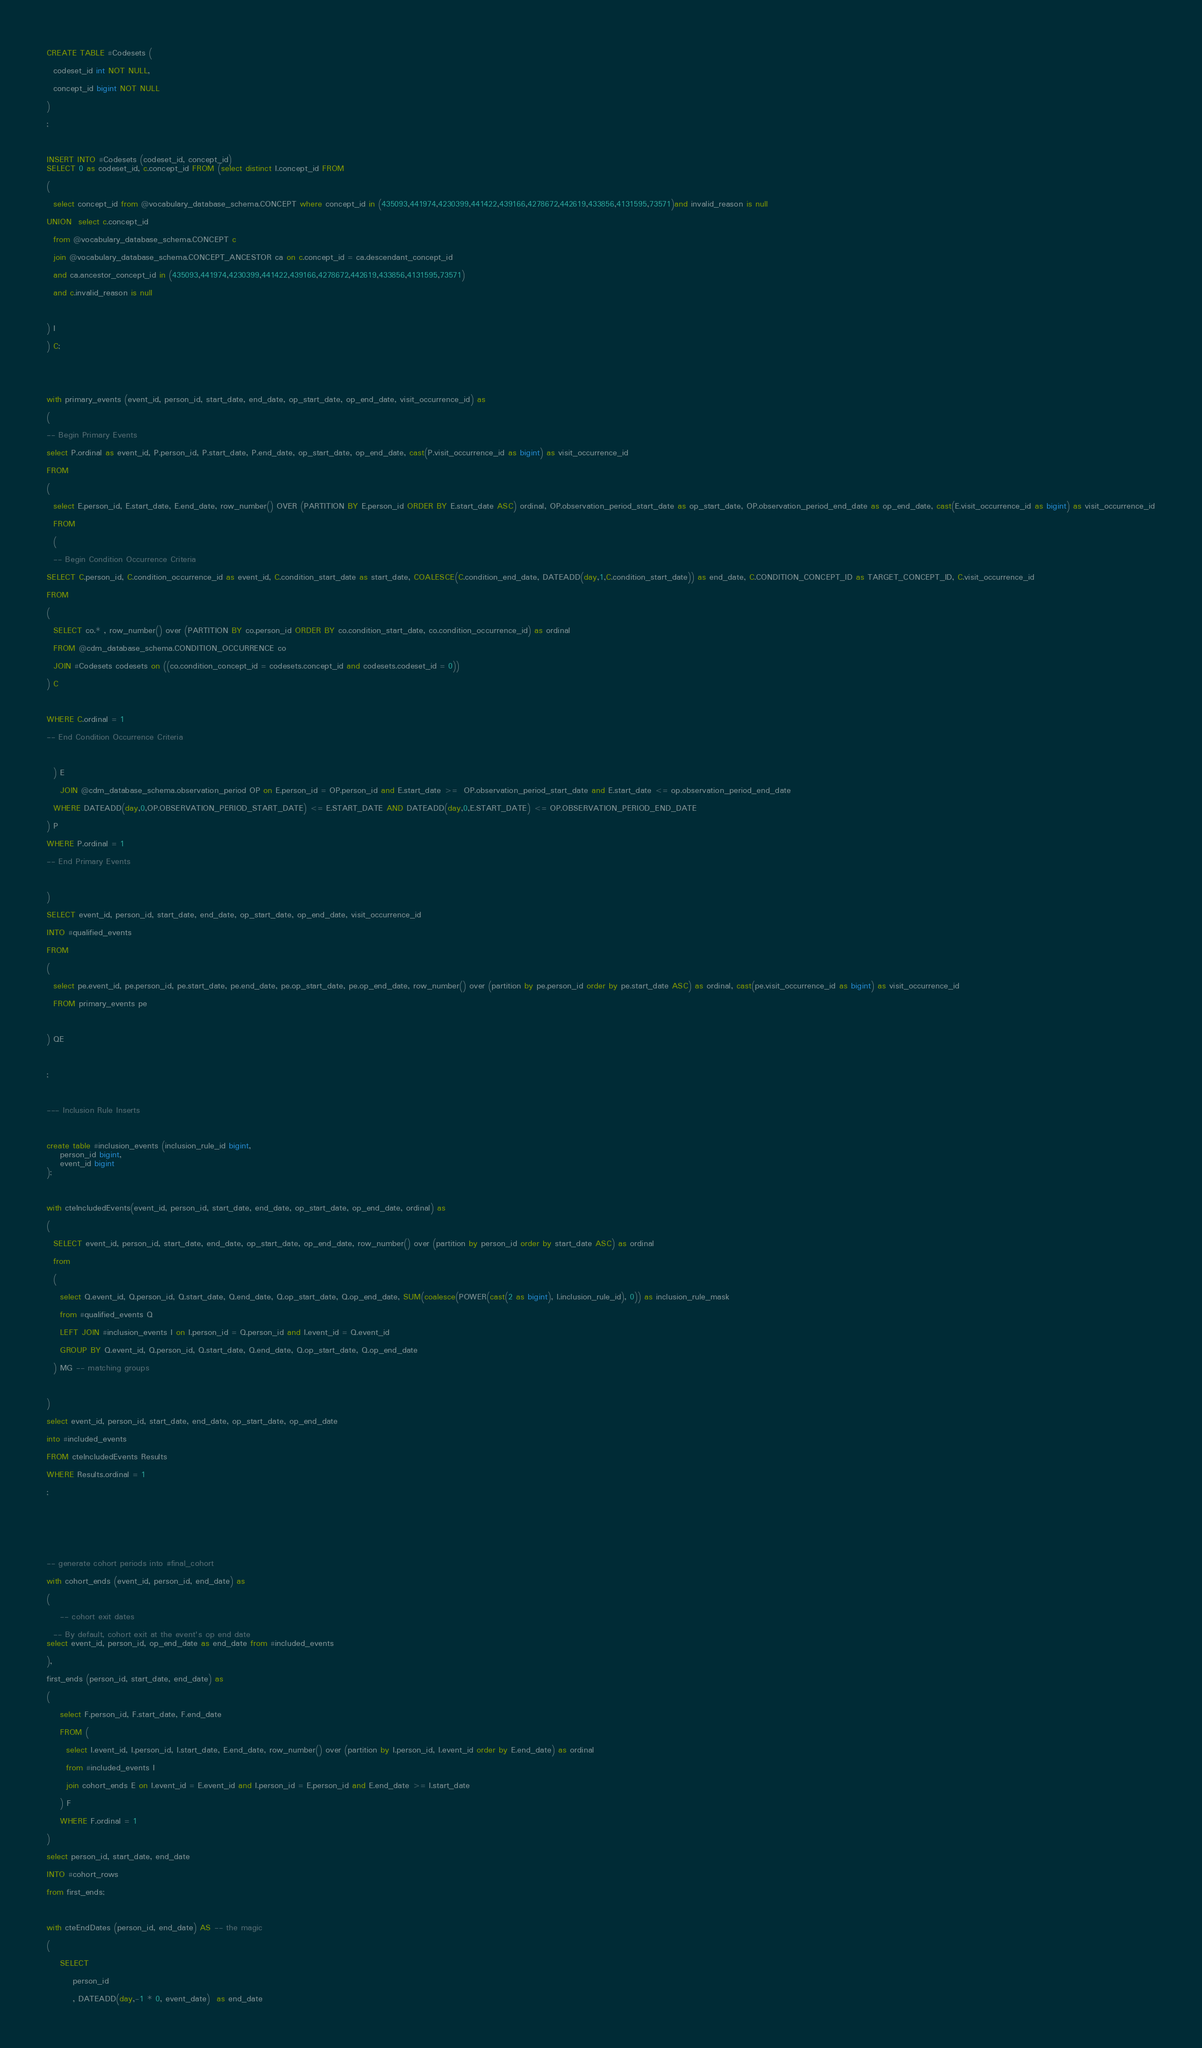Convert code to text. <code><loc_0><loc_0><loc_500><loc_500><_SQL_>CREATE TABLE #Codesets (
  codeset_id int NOT NULL,
  concept_id bigint NOT NULL
)
;

INSERT INTO #Codesets (codeset_id, concept_id)
SELECT 0 as codeset_id, c.concept_id FROM (select distinct I.concept_id FROM
( 
  select concept_id from @vocabulary_database_schema.CONCEPT where concept_id in (435093,441974,4230399,441422,439166,4278672,442619,433856,4131595,73571)and invalid_reason is null
UNION  select c.concept_id
  from @vocabulary_database_schema.CONCEPT c
  join @vocabulary_database_schema.CONCEPT_ANCESTOR ca on c.concept_id = ca.descendant_concept_id
  and ca.ancestor_concept_id in (435093,441974,4230399,441422,439166,4278672,442619,433856,4131595,73571)
  and c.invalid_reason is null

) I
) C;


with primary_events (event_id, person_id, start_date, end_date, op_start_date, op_end_date, visit_occurrence_id) as
(
-- Begin Primary Events
select P.ordinal as event_id, P.person_id, P.start_date, P.end_date, op_start_date, op_end_date, cast(P.visit_occurrence_id as bigint) as visit_occurrence_id
FROM
(
  select E.person_id, E.start_date, E.end_date, row_number() OVER (PARTITION BY E.person_id ORDER BY E.start_date ASC) ordinal, OP.observation_period_start_date as op_start_date, OP.observation_period_end_date as op_end_date, cast(E.visit_occurrence_id as bigint) as visit_occurrence_id
  FROM 
  (
  -- Begin Condition Occurrence Criteria
SELECT C.person_id, C.condition_occurrence_id as event_id, C.condition_start_date as start_date, COALESCE(C.condition_end_date, DATEADD(day,1,C.condition_start_date)) as end_date, C.CONDITION_CONCEPT_ID as TARGET_CONCEPT_ID, C.visit_occurrence_id
FROM 
(
  SELECT co.* , row_number() over (PARTITION BY co.person_id ORDER BY co.condition_start_date, co.condition_occurrence_id) as ordinal
  FROM @cdm_database_schema.CONDITION_OCCURRENCE co
  JOIN #Codesets codesets on ((co.condition_concept_id = codesets.concept_id and codesets.codeset_id = 0))
) C

WHERE C.ordinal = 1
-- End Condition Occurrence Criteria

  ) E
	JOIN @cdm_database_schema.observation_period OP on E.person_id = OP.person_id and E.start_date >=  OP.observation_period_start_date and E.start_date <= op.observation_period_end_date
  WHERE DATEADD(day,0,OP.OBSERVATION_PERIOD_START_DATE) <= E.START_DATE AND DATEADD(day,0,E.START_DATE) <= OP.OBSERVATION_PERIOD_END_DATE
) P
WHERE P.ordinal = 1
-- End Primary Events

)
SELECT event_id, person_id, start_date, end_date, op_start_date, op_end_date, visit_occurrence_id
INTO #qualified_events
FROM 
(
  select pe.event_id, pe.person_id, pe.start_date, pe.end_date, pe.op_start_date, pe.op_end_date, row_number() over (partition by pe.person_id order by pe.start_date ASC) as ordinal, cast(pe.visit_occurrence_id as bigint) as visit_occurrence_id
  FROM primary_events pe
  
) QE

;

--- Inclusion Rule Inserts

create table #inclusion_events (inclusion_rule_id bigint,
	person_id bigint,
	event_id bigint
);

with cteIncludedEvents(event_id, person_id, start_date, end_date, op_start_date, op_end_date, ordinal) as
(
  SELECT event_id, person_id, start_date, end_date, op_start_date, op_end_date, row_number() over (partition by person_id order by start_date ASC) as ordinal
  from
  (
    select Q.event_id, Q.person_id, Q.start_date, Q.end_date, Q.op_start_date, Q.op_end_date, SUM(coalesce(POWER(cast(2 as bigint), I.inclusion_rule_id), 0)) as inclusion_rule_mask
    from #qualified_events Q
    LEFT JOIN #inclusion_events I on I.person_id = Q.person_id and I.event_id = Q.event_id
    GROUP BY Q.event_id, Q.person_id, Q.start_date, Q.end_date, Q.op_start_date, Q.op_end_date
  ) MG -- matching groups

)
select event_id, person_id, start_date, end_date, op_start_date, op_end_date
into #included_events
FROM cteIncludedEvents Results
WHERE Results.ordinal = 1
;



-- generate cohort periods into #final_cohort
with cohort_ends (event_id, person_id, end_date) as
(
	-- cohort exit dates
  -- By default, cohort exit at the event's op end date
select event_id, person_id, op_end_date as end_date from #included_events
),
first_ends (person_id, start_date, end_date) as
(
	select F.person_id, F.start_date, F.end_date
	FROM (
	  select I.event_id, I.person_id, I.start_date, E.end_date, row_number() over (partition by I.person_id, I.event_id order by E.end_date) as ordinal 
	  from #included_events I
	  join cohort_ends E on I.event_id = E.event_id and I.person_id = E.person_id and E.end_date >= I.start_date
	) F
	WHERE F.ordinal = 1
)
select person_id, start_date, end_date
INTO #cohort_rows
from first_ends;

with cteEndDates (person_id, end_date) AS -- the magic
(	
	SELECT
		person_id
		, DATEADD(day,-1 * 0, event_date)  as end_date</code> 